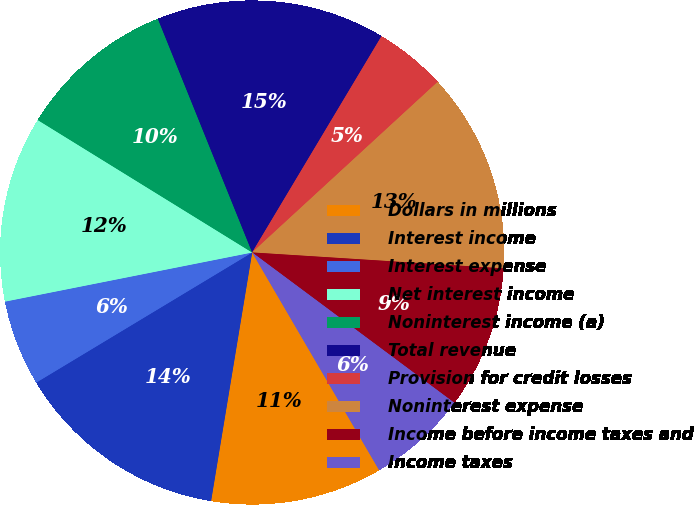Convert chart. <chart><loc_0><loc_0><loc_500><loc_500><pie_chart><fcel>Dollars in millions<fcel>Interest income<fcel>Interest expense<fcel>Net interest income<fcel>Noninterest income (a)<fcel>Total revenue<fcel>Provision for credit losses<fcel>Noninterest expense<fcel>Income before income taxes and<fcel>Income taxes<nl><fcel>11.01%<fcel>13.76%<fcel>5.51%<fcel>11.93%<fcel>10.09%<fcel>14.68%<fcel>4.59%<fcel>12.84%<fcel>9.17%<fcel>6.42%<nl></chart> 